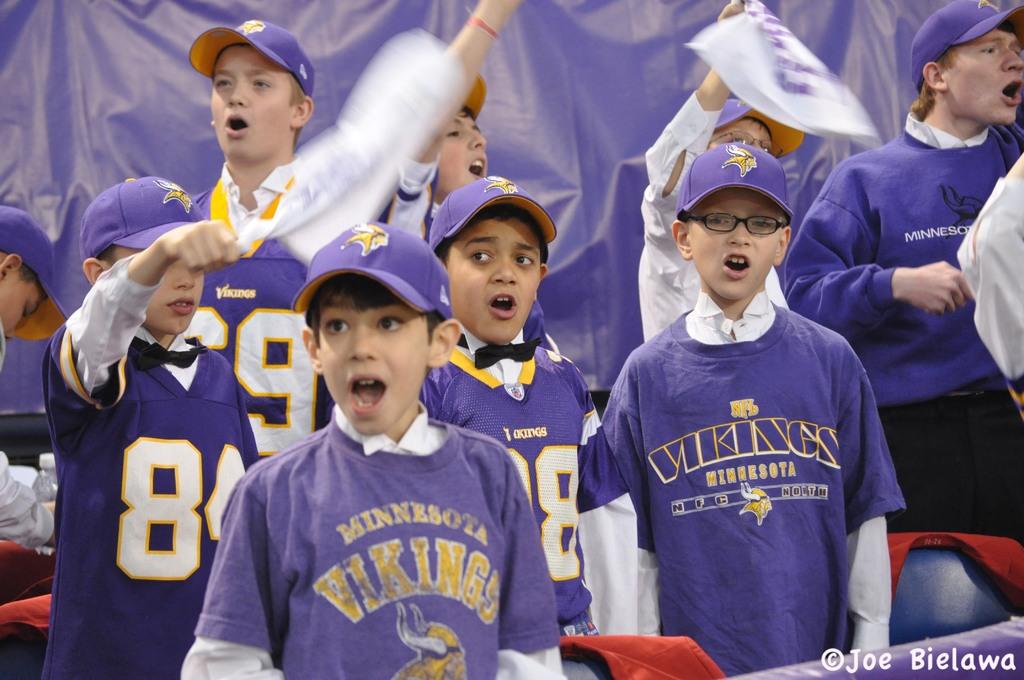What team is on the children's shirts?
Provide a succinct answer. Vikings. Who took this picture?
Give a very brief answer. Joe bielawa. 